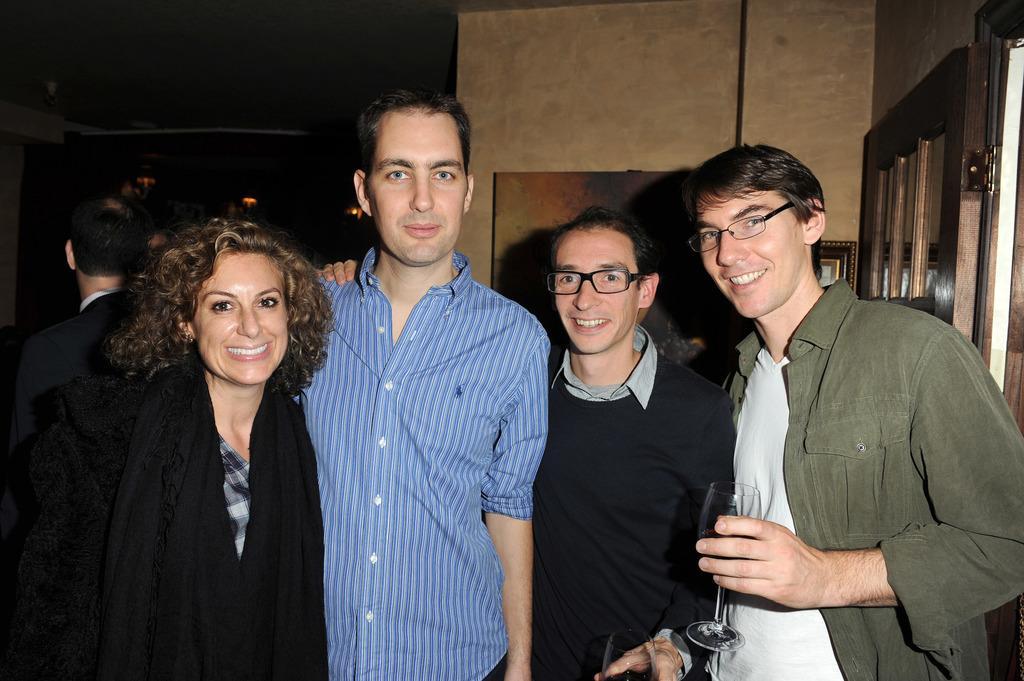In one or two sentences, can you explain what this image depicts? In this image we can see a group of persons and among them there are few people holding glasses. Behind the persons we can see a wall and on the wall we can see a board. On the right side, we can see a door. 